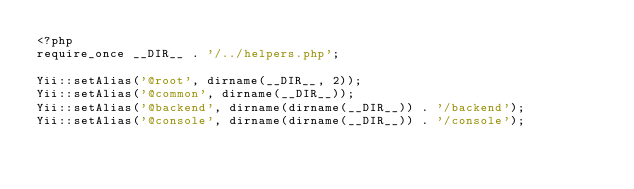Convert code to text. <code><loc_0><loc_0><loc_500><loc_500><_PHP_><?php
require_once __DIR__ . '/../helpers.php';

Yii::setAlias('@root', dirname(__DIR__, 2));
Yii::setAlias('@common', dirname(__DIR__));
Yii::setAlias('@backend', dirname(dirname(__DIR__)) . '/backend');
Yii::setAlias('@console', dirname(dirname(__DIR__)) . '/console');
</code> 